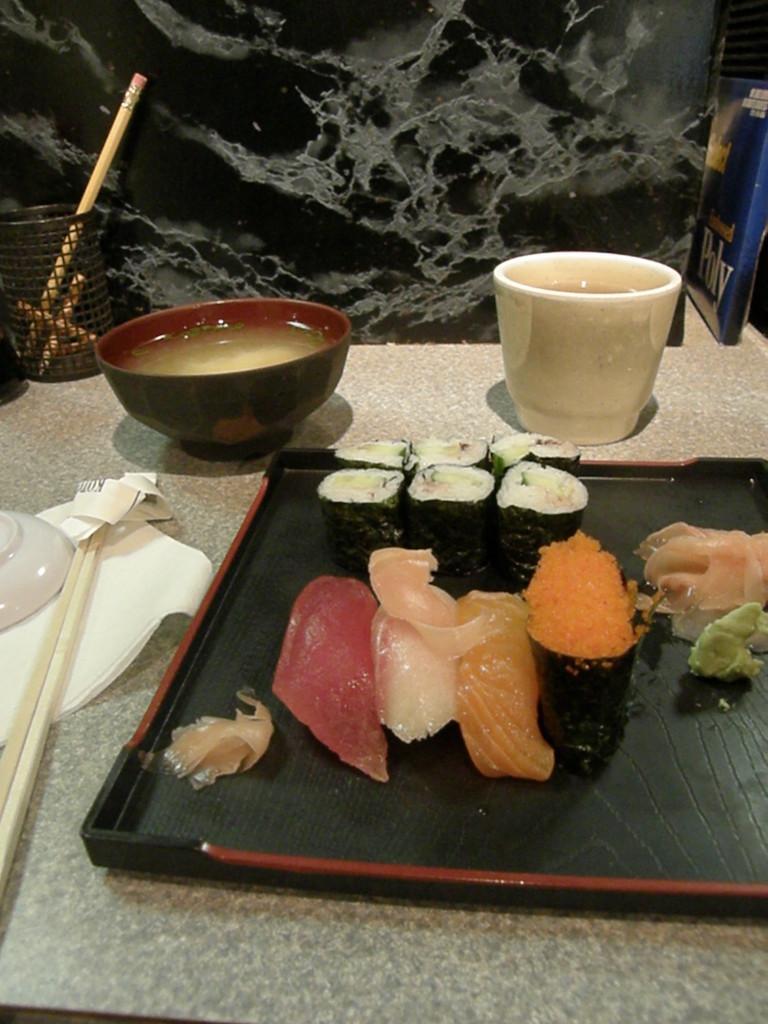Please provide a concise description of this image. There is a plate of black color, In that place there are some food items and there is a cup of white color and there is a bowl of black color, In the background there is a wall of black color. 